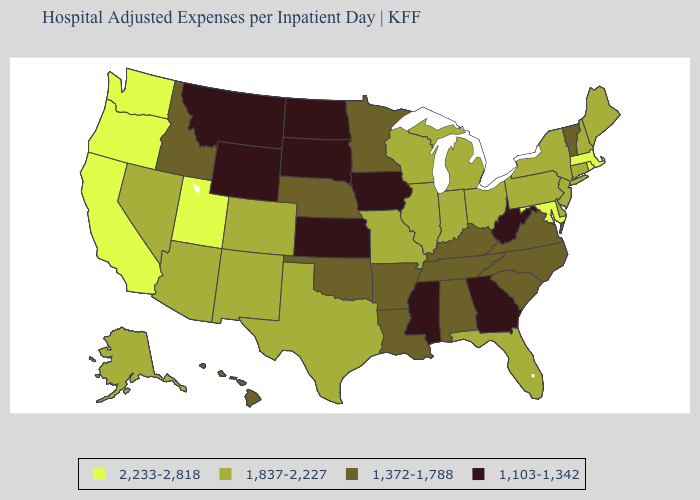What is the value of Minnesota?
Quick response, please. 1,372-1,788. What is the value of Wyoming?
Keep it brief. 1,103-1,342. Does Kansas have the same value as Georgia?
Short answer required. Yes. Name the states that have a value in the range 1,837-2,227?
Concise answer only. Alaska, Arizona, Colorado, Connecticut, Delaware, Florida, Illinois, Indiana, Maine, Michigan, Missouri, Nevada, New Hampshire, New Jersey, New Mexico, New York, Ohio, Pennsylvania, Texas, Wisconsin. Does Rhode Island have the same value as Washington?
Be succinct. Yes. What is the highest value in states that border Florida?
Give a very brief answer. 1,372-1,788. What is the value of Michigan?
Give a very brief answer. 1,837-2,227. What is the lowest value in the USA?
Write a very short answer. 1,103-1,342. Among the states that border North Carolina , which have the highest value?
Quick response, please. South Carolina, Tennessee, Virginia. What is the highest value in the USA?
Be succinct. 2,233-2,818. Does the first symbol in the legend represent the smallest category?
Give a very brief answer. No. Does Vermont have a higher value than New Hampshire?
Answer briefly. No. Does the first symbol in the legend represent the smallest category?
Write a very short answer. No. What is the value of Colorado?
Be succinct. 1,837-2,227. Does Arizona have the lowest value in the West?
Concise answer only. No. 